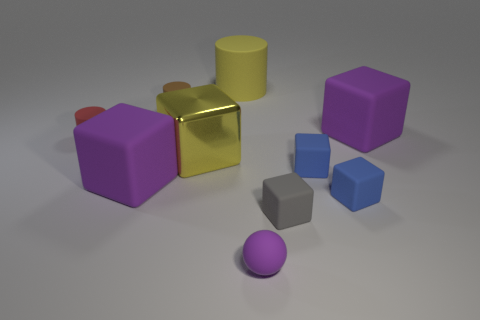How many yellow objects are the same shape as the gray object?
Provide a short and direct response. 1. Do the large matte thing to the left of the yellow cylinder and the sphere have the same color?
Your response must be concise. Yes. What number of rubber objects are either large yellow things or blue spheres?
Your response must be concise. 1. Is the number of brown cylinders less than the number of large brown things?
Your answer should be very brief. No. How many other objects are the same material as the tiny purple object?
Your answer should be very brief. 8. There is a yellow metallic thing that is the same shape as the small gray rubber thing; what size is it?
Your answer should be very brief. Large. Is the purple block in front of the red cylinder made of the same material as the big yellow object that is in front of the large cylinder?
Offer a very short reply. No. Are there fewer yellow metal blocks behind the red cylinder than big blue spheres?
Provide a short and direct response. No. Are there any other things that are the same shape as the small purple thing?
Keep it short and to the point. No. What color is the large rubber thing that is the same shape as the small brown rubber thing?
Your answer should be compact. Yellow. 